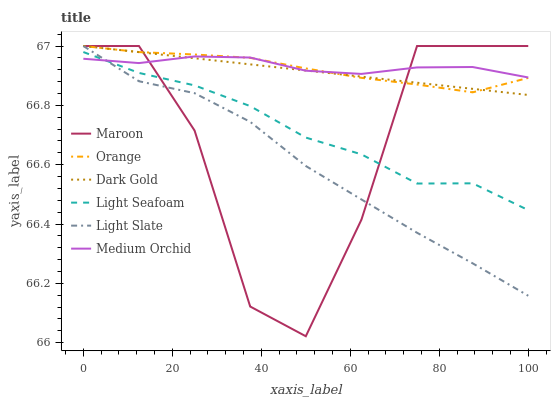Does Light Slate have the minimum area under the curve?
Answer yes or no. Yes. Does Medium Orchid have the maximum area under the curve?
Answer yes or no. Yes. Does Medium Orchid have the minimum area under the curve?
Answer yes or no. No. Does Light Slate have the maximum area under the curve?
Answer yes or no. No. Is Dark Gold the smoothest?
Answer yes or no. Yes. Is Maroon the roughest?
Answer yes or no. Yes. Is Light Slate the smoothest?
Answer yes or no. No. Is Light Slate the roughest?
Answer yes or no. No. Does Maroon have the lowest value?
Answer yes or no. Yes. Does Light Slate have the lowest value?
Answer yes or no. No. Does Orange have the highest value?
Answer yes or no. Yes. Does Medium Orchid have the highest value?
Answer yes or no. No. Is Light Seafoam less than Orange?
Answer yes or no. Yes. Is Dark Gold greater than Light Seafoam?
Answer yes or no. Yes. Does Orange intersect Maroon?
Answer yes or no. Yes. Is Orange less than Maroon?
Answer yes or no. No. Is Orange greater than Maroon?
Answer yes or no. No. Does Light Seafoam intersect Orange?
Answer yes or no. No. 